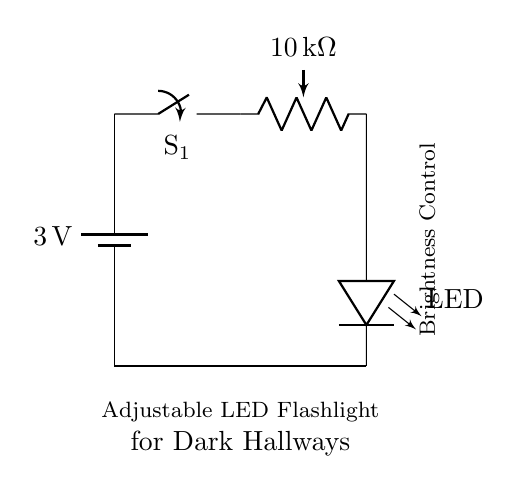What is the voltage of the battery? The battery in the circuit is labeled as 3 volts, indicating the electrical potential provided by it.
Answer: 3 volts What is the purpose of the switch in this circuit? The switch, labeled S1, is used to open or close the circuit, allowing the user to control whether the flashlight is on or off.
Answer: Control circuit How many components are in this circuit? The circuit includes four components: a battery, a switch, a potentiometer, and an LED.
Answer: Four What is the function of the potentiometer? The potentiometer, labeled as 10 kilohms, is used to adjust the resistance in the circuit, allowing the user to change the brightness of the LED.
Answer: Brightness control What happens if the potentiometer is turned to its maximum resistance? Turning the potentiometer to maximum resistance will decrease the current flowing through the circuit, resulting in a dimmer light from the LED.
Answer: Dim light How does the brightness control affect the LED? As the resistance of the potentiometer increases, the current through the LED decreases, which directly affects the brightness — more resistance leads to less current and dimmer light.
Answer: Adjusts brightness 